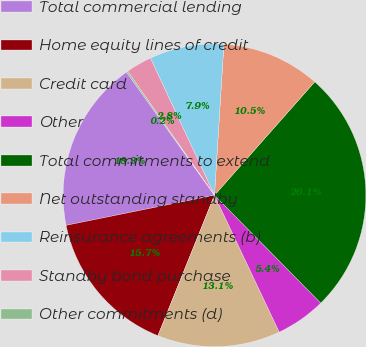Convert chart to OTSL. <chart><loc_0><loc_0><loc_500><loc_500><pie_chart><fcel>Total commercial lending<fcel>Home equity lines of credit<fcel>Credit card<fcel>Other<fcel>Total commitments to extend<fcel>Net outstanding standby<fcel>Reinsurance agreements (b)<fcel>Standby bond purchase<fcel>Other commitments (d)<nl><fcel>18.31%<fcel>15.72%<fcel>13.13%<fcel>5.35%<fcel>26.09%<fcel>10.53%<fcel>7.94%<fcel>2.76%<fcel>0.16%<nl></chart> 